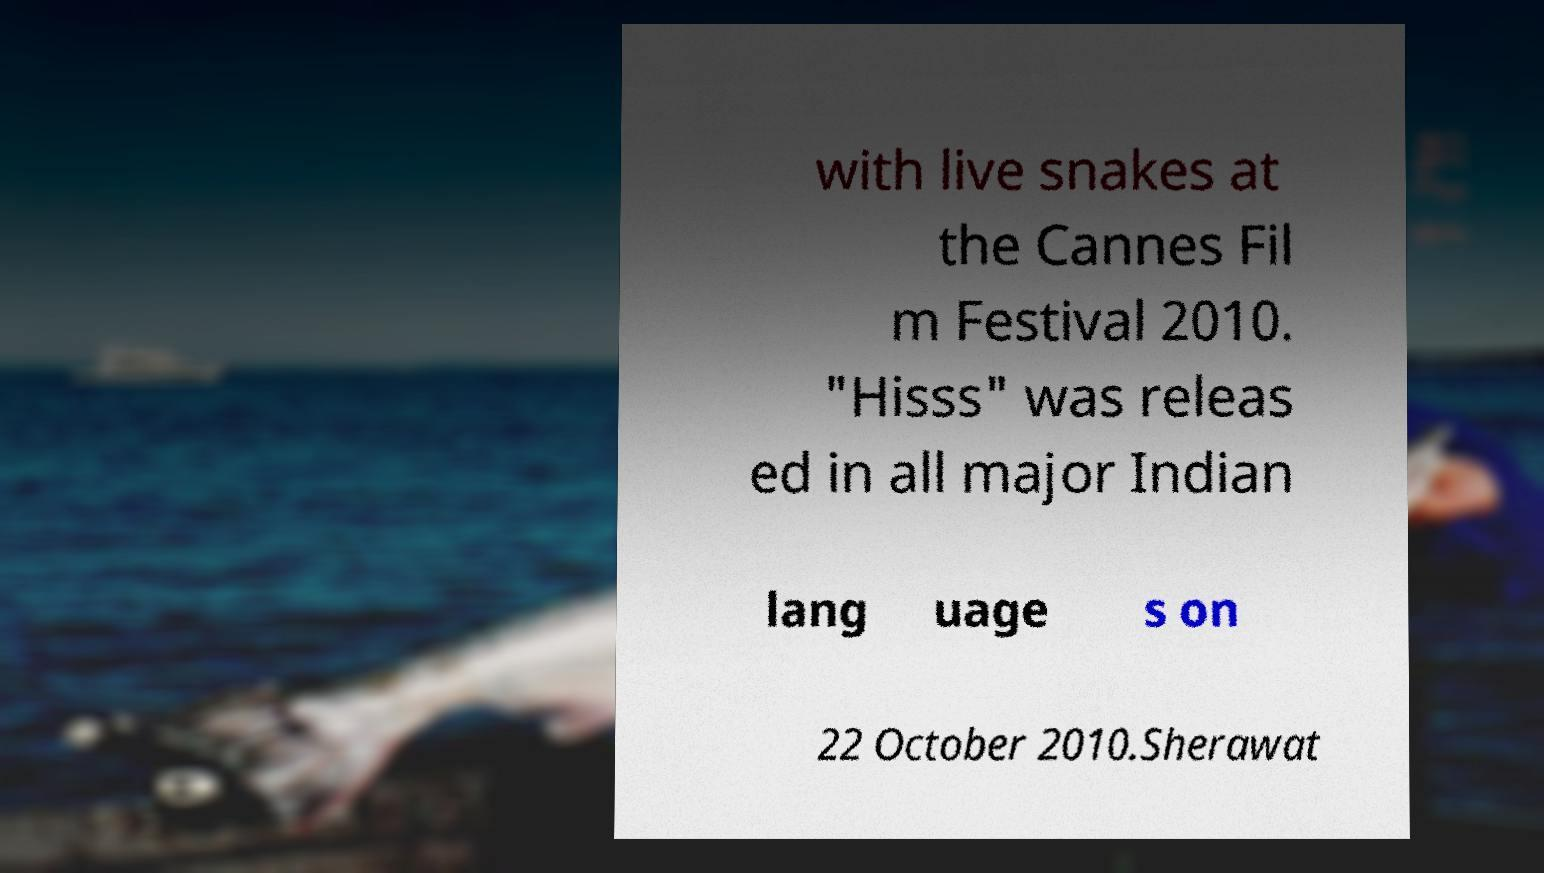There's text embedded in this image that I need extracted. Can you transcribe it verbatim? with live snakes at the Cannes Fil m Festival 2010. "Hisss" was releas ed in all major Indian lang uage s on 22 October 2010.Sherawat 